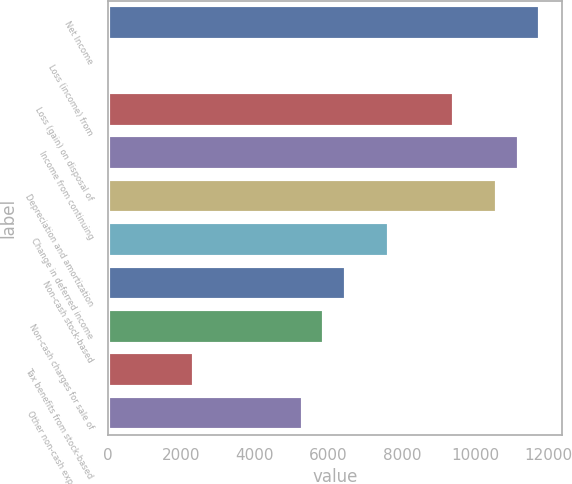<chart> <loc_0><loc_0><loc_500><loc_500><bar_chart><fcel>Net Income<fcel>Loss (income) from<fcel>Loss (gain) on disposal of<fcel>Income from continuing<fcel>Depreciation and amortization<fcel>Change in deferred income<fcel>Non-cash stock-based<fcel>Non-cash charges for sale of<fcel>Tax benefits from stock-based<fcel>Other non-cash expenses net<nl><fcel>11774.5<fcel>1.7<fcel>9419.94<fcel>11185.9<fcel>10597.2<fcel>7654.02<fcel>6476.74<fcel>5888.1<fcel>2356.26<fcel>5299.46<nl></chart> 